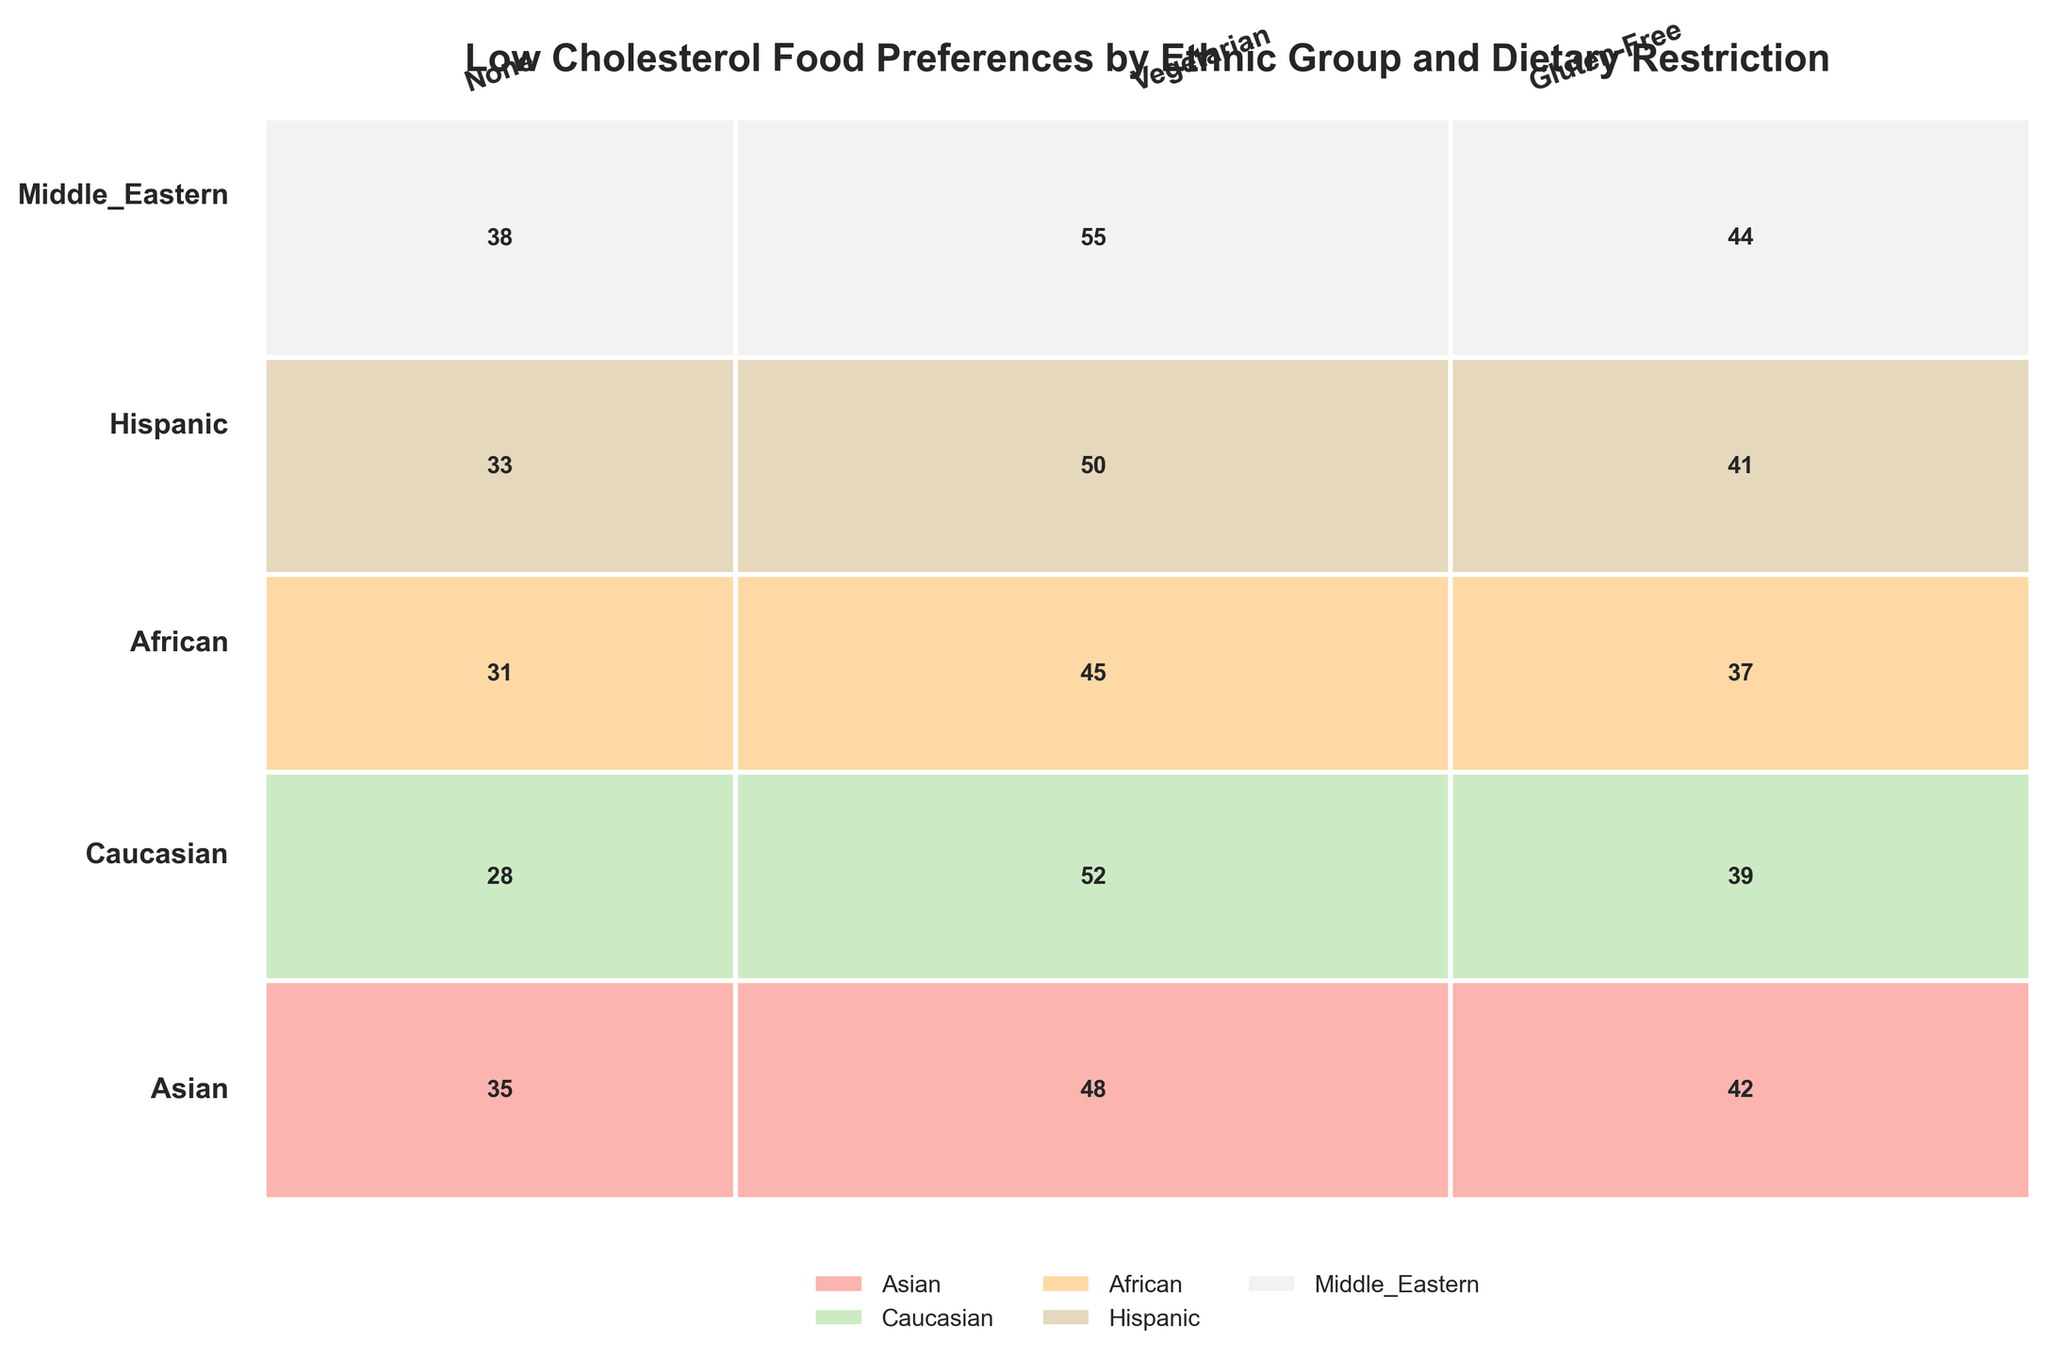what is the title of the figure? The title of the figure is usually displayed at the top center of the chart in a larger and bolder font. Reading it directly provides us with the information.
Answer: Low Cholesterol Food Preferences by Ethnic Group and Dietary Restriction which ethnic group has the highest preference for low cholesterol foods in the vegetarian category? By locating the columns labeled "Vegetarian" and checking the rectangles' values linked with each ethnic group, we identify which one has the highest value.
Answer: Middle Eastern how do the preferences for low cholesterol foods between gluten-free and vegetarian diets compare within the Asian ethnic group? By examining the Asian row, we compare the values in the gluten-free and vegetarian columns. The comparison shows that the value for vegetarians is higher.
Answer: Vegetarian has a higher preference what total count of low cholesterol food preferences is recorded for the Hispanic ethnic group? Summing the values recorded for the Hispanic group across all dietary restrictions (None, Vegetarian, and Gluten-Free) gives the total count.
Answer: 124 which dietary restriction shows the smallest total preference for low cholesterol foods across all ethnic groups? Summing preferences within each dietary restriction column and comparing these sums highlight which has the smallest total.
Answer: Gluten-Free which ethnic group displays the closest values for low cholesterol preferences across all three dietary restrictions? By reviewing the values within each ethnic row, we identify the one with the least variation among its three categories. Asian group values (35, 48, 42) are observed to be quite close.
Answer: Asian what’s the combined preference for low cholesterol foods seen in Caucasian and African ethnic groups under the vegetarian dietary restriction? Adding the Vegetarian values for both Caucasian and African groups gives the combined preference.
Answer: 97 compare the preferences of Middle Eastern and Hispanic groups for low cholesterol foods in the none dietary restriction. By observing the "None" column, it's evident that the Middle Eastern group has a higher value compared to the Hispanic group.
Answer: Middle Eastern which dietary restriction has the highest number of total preferences across all groups? Summing up preferences within each dietary restriction column and identifying the highest total helps us determine this.
Answer: Vegetarian what percentage of the total preferences does the Asian ethnic group possess? By dividing the sum of preferences for the Asian group by the grand total and multiplying by 100, the percentage contribution of the Asian group is computed. (35+48+42)/(sum of all values) * 100.
Answer: 18.89% 